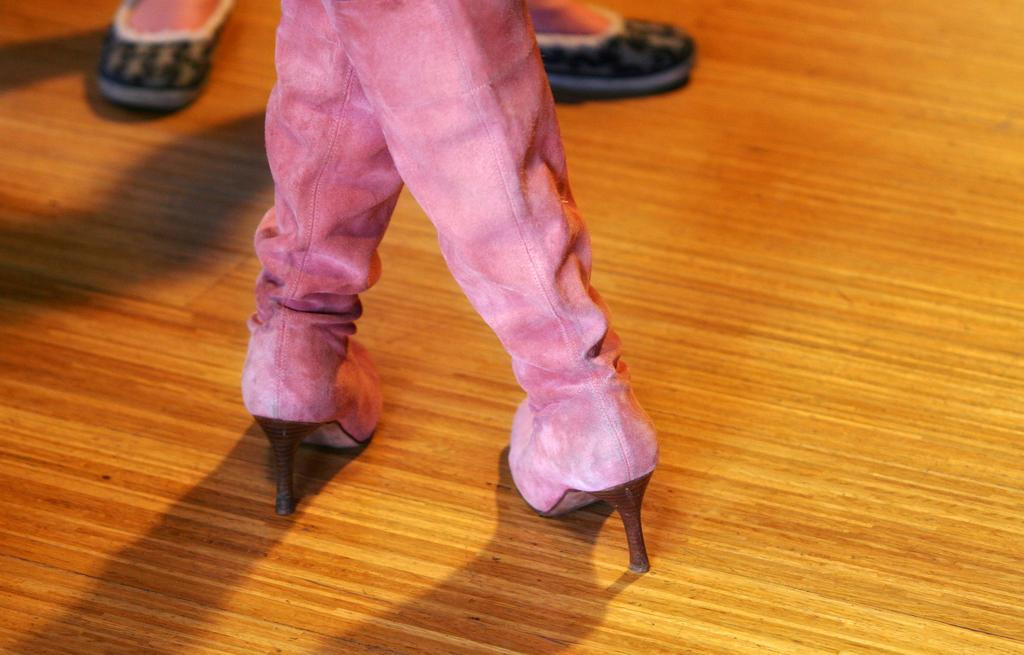What type of footwear is the woman wearing in the image? The woman is wearing heels in the image. Can you describe any other visible body parts in the image? Yes, there are legs visible in the image. What type of squirrel can be seen sitting quietly on the woman's shoulder in the image? There is no squirrel present in the image. What type of owl can be heard hooting in the background of the image? There is no sound or owl present in the image. 